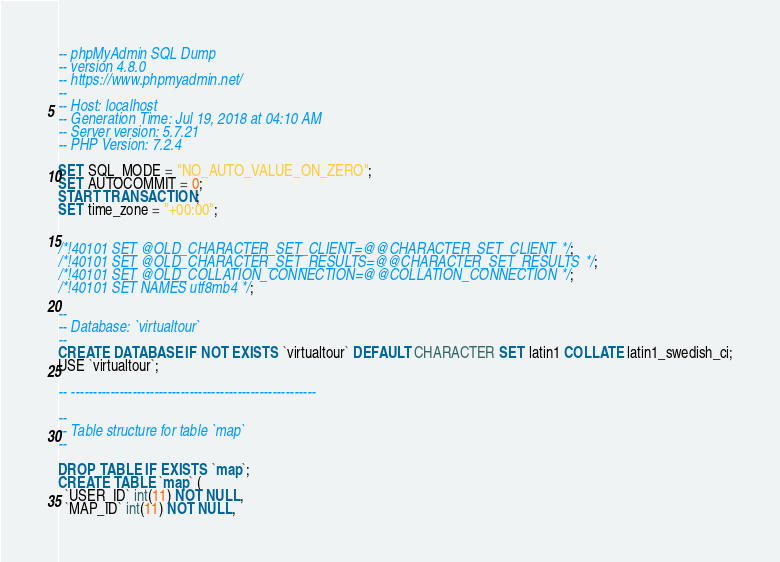<code> <loc_0><loc_0><loc_500><loc_500><_SQL_>-- phpMyAdmin SQL Dump
-- version 4.8.0
-- https://www.phpmyadmin.net/
--
-- Host: localhost
-- Generation Time: Jul 19, 2018 at 04:10 AM
-- Server version: 5.7.21
-- PHP Version: 7.2.4

SET SQL_MODE = "NO_AUTO_VALUE_ON_ZERO";
SET AUTOCOMMIT = 0;
START TRANSACTION;
SET time_zone = "+00:00";


/*!40101 SET @OLD_CHARACTER_SET_CLIENT=@@CHARACTER_SET_CLIENT */;
/*!40101 SET @OLD_CHARACTER_SET_RESULTS=@@CHARACTER_SET_RESULTS */;
/*!40101 SET @OLD_COLLATION_CONNECTION=@@COLLATION_CONNECTION */;
/*!40101 SET NAMES utf8mb4 */;

--
-- Database: `virtualtour`
--
CREATE DATABASE IF NOT EXISTS `virtualtour` DEFAULT CHARACTER SET latin1 COLLATE latin1_swedish_ci;
USE `virtualtour`;

-- --------------------------------------------------------

--
-- Table structure for table `map`
--

DROP TABLE IF EXISTS `map`;
CREATE TABLE `map` (
  `USER_ID` int(11) NOT NULL,
  `MAP_ID` int(11) NOT NULL,</code> 